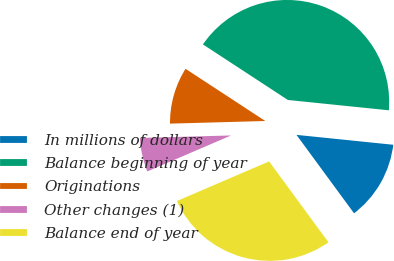<chart> <loc_0><loc_0><loc_500><loc_500><pie_chart><fcel>In millions of dollars<fcel>Balance beginning of year<fcel>Originations<fcel>Other changes (1)<fcel>Balance end of year<nl><fcel>13.3%<fcel>42.4%<fcel>9.66%<fcel>6.02%<fcel>28.62%<nl></chart> 